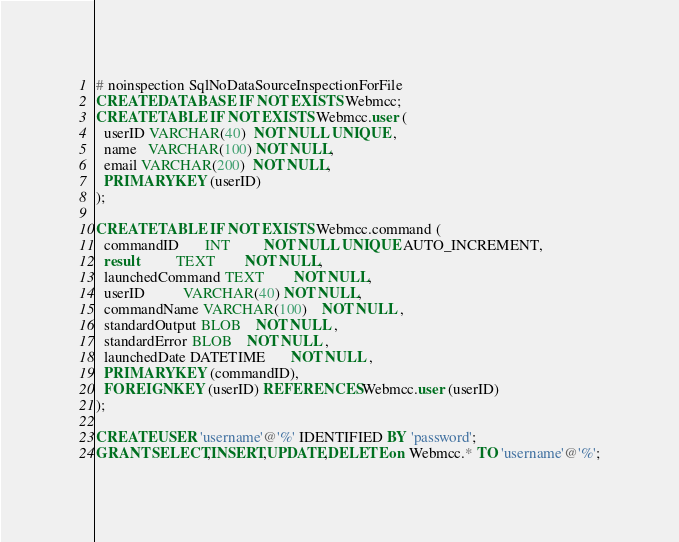Convert code to text. <code><loc_0><loc_0><loc_500><loc_500><_SQL_># noinspection SqlNoDataSourceInspectionForFile
CREATE DATABASE IF NOT EXISTS Webmcc;
CREATE TABLE IF NOT EXISTS Webmcc.user (
  userID VARCHAR(40)  NOT NULL UNIQUE ,
  name   VARCHAR(100) NOT NULL,
  email VARCHAR(200)  NOT NULL,
  PRIMARY KEY (userID)
);

CREATE TABLE IF NOT EXISTS Webmcc.command (
  commandID       INT         NOT NULL UNIQUE AUTO_INCREMENT,
  result          TEXT        NOT NULL,
  launchedCommand TEXT        NOT NULL,
  userID          VARCHAR(40) NOT NULL,
  commandName VARCHAR(100)    NOT NULL ,
  standardOutput BLOB    NOT NULL ,
  standardError BLOB    NOT NULL ,
  launchedDate DATETIME       NOT NULL ,
  PRIMARY KEY (commandID),
  FOREIGN KEY (userID) REFERENCES Webmcc.user (userID)
);

CREATE USER 'username'@'%' IDENTIFIED BY 'password';
GRANT SELECT,INSERT,UPDATE,DELETE on Webmcc.* TO 'username'@'%';</code> 